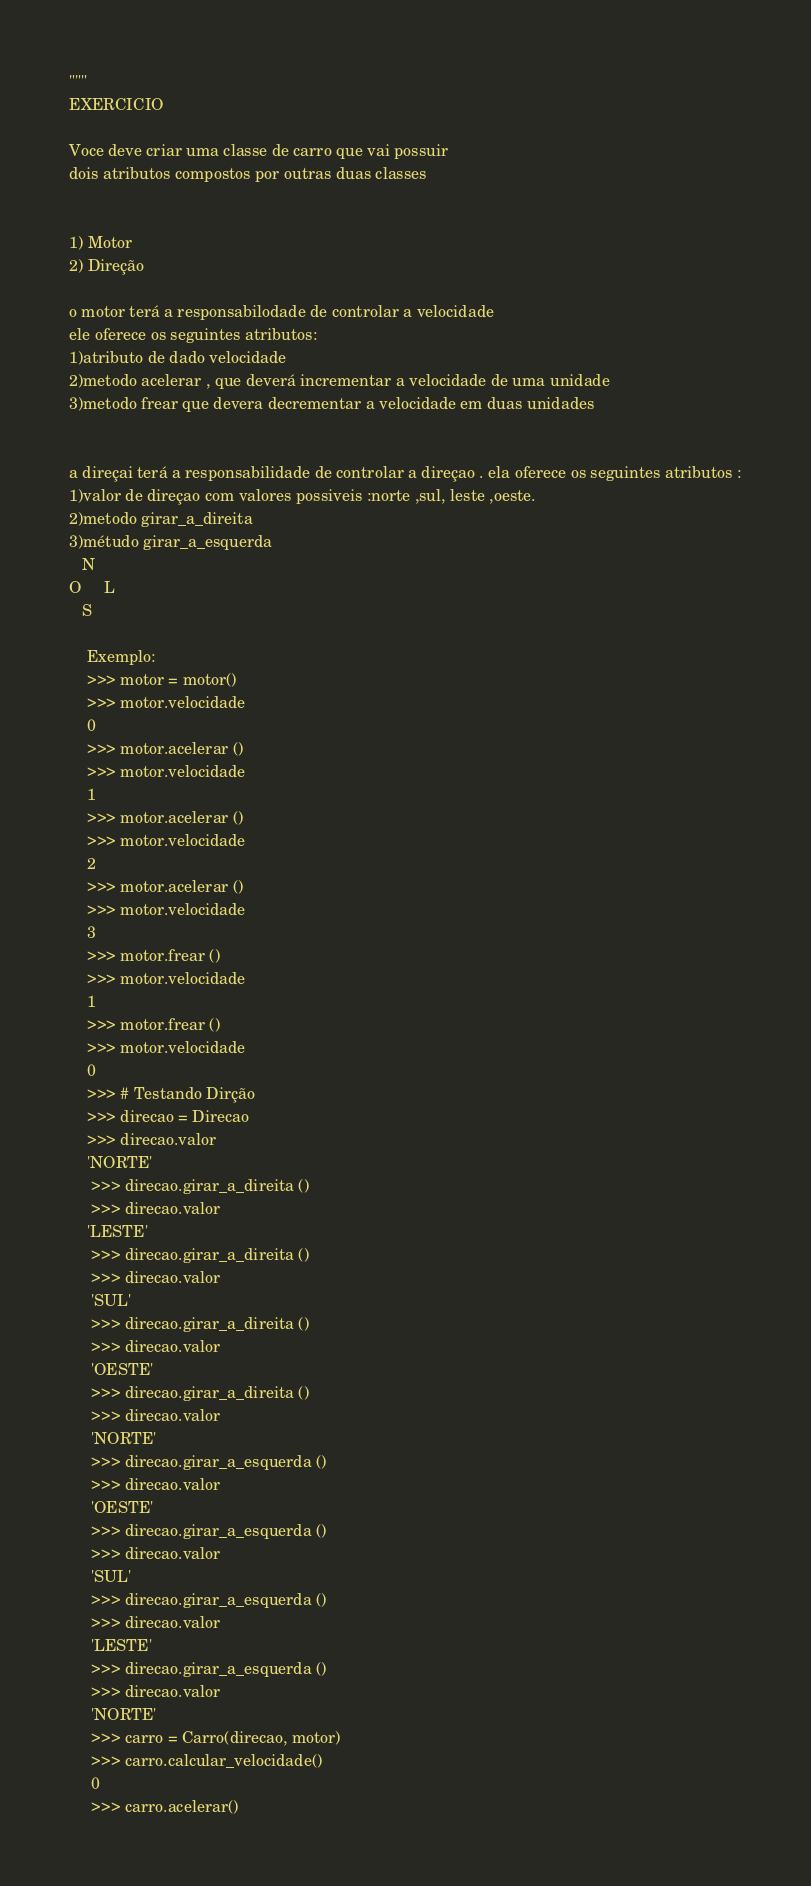<code> <loc_0><loc_0><loc_500><loc_500><_Python_>
"""
EXERCICIO

Voce deve criar uma classe de carro que vai possuir
dois atributos compostos por outras duas classes


1) Motor
2) Direção

o motor terá a responsabilodade de controlar a velocidade
ele oferece os seguintes atributos:
1)atributo de dado velocidade
2)metodo acelerar , que deverá incrementar a velocidade de uma unidade
3)metodo frear que devera decrementar a velocidade em duas unidades


a direçai terá a responsabilidade de controlar a direçao . ela oferece os seguintes atributos :
1)valor de direçao com valores possiveis :norte ,sul, leste ,oeste.
2)metodo girar_a_direita
3)métudo girar_a_esquerda
   N
O     L
   S

    Exemplo:
    >>> motor = motor()
    >>> motor.velocidade
    0
    >>> motor.acelerar ()
    >>> motor.velocidade
    1
    >>> motor.acelerar ()
    >>> motor.velocidade
    2
    >>> motor.acelerar ()
    >>> motor.velocidade
    3
    >>> motor.frear ()
    >>> motor.velocidade
    1
    >>> motor.frear ()
    >>> motor.velocidade
    0
    >>> # Testando Dirção
    >>> direcao = Direcao
    >>> direcao.valor
    'NORTE'
     >>> direcao.girar_a_direita ()
     >>> direcao.valor
    'LESTE'
     >>> direcao.girar_a_direita ()
     >>> direcao.valor
     'SUL'
     >>> direcao.girar_a_direita ()
     >>> direcao.valor
     'OESTE'
     >>> direcao.girar_a_direita ()
     >>> direcao.valor
     'NORTE'
     >>> direcao.girar_a_esquerda ()
     >>> direcao.valor
     'OESTE'
     >>> direcao.girar_a_esquerda ()
     >>> direcao.valor
     'SUL'
     >>> direcao.girar_a_esquerda ()
     >>> direcao.valor
     'LESTE'
     >>> direcao.girar_a_esquerda ()
     >>> direcao.valor
     'NORTE'
     >>> carro = Carro(direcao, motor)
     >>> carro.calcular_velocidade()
     0
     >>> carro.acelerar()</code> 